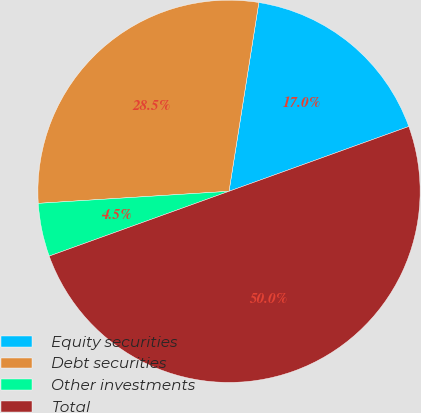Convert chart to OTSL. <chart><loc_0><loc_0><loc_500><loc_500><pie_chart><fcel>Equity securities<fcel>Debt securities<fcel>Other investments<fcel>Total<nl><fcel>17.0%<fcel>28.5%<fcel>4.5%<fcel>50.0%<nl></chart> 